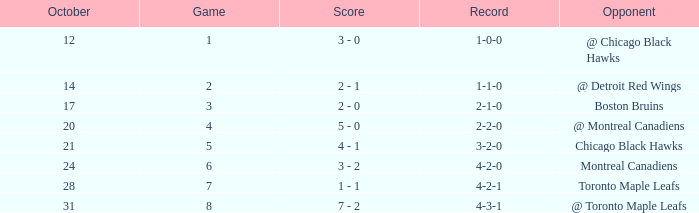What was the record for the game before game 6 against the chicago black hawks? 3-2-0. 